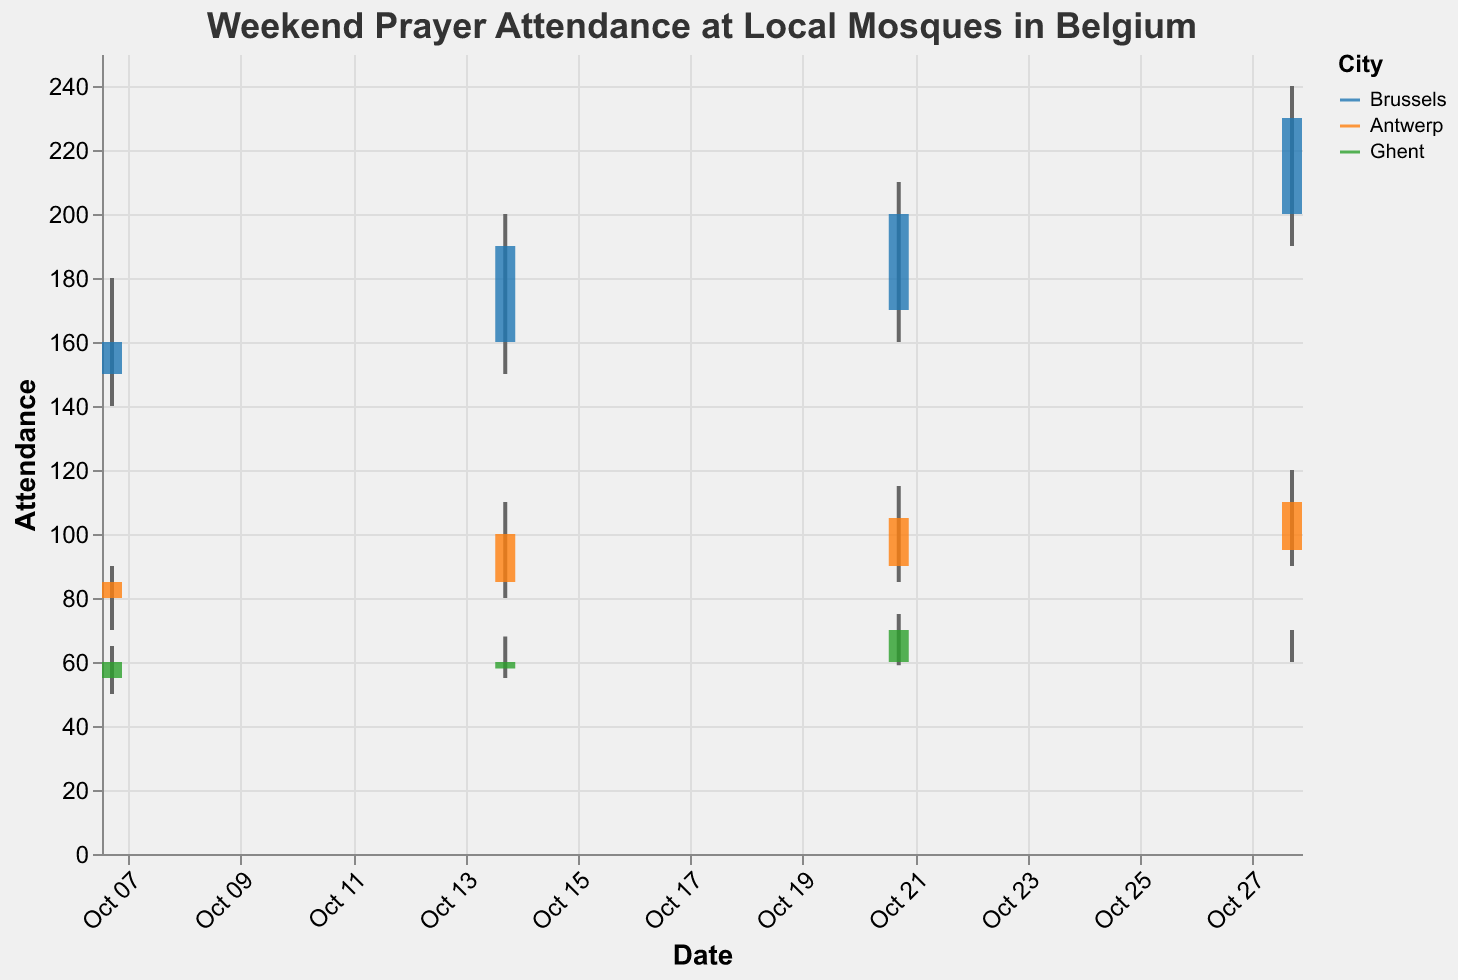What is the title of the plot? The title is usually placed at the top of the plot and specifies what the plot represents.
Answer: Weekend Prayer Attendance at Local Mosques in Belgium Which city has the highest attendance on October 28, 2023? Look at the high values for October 28, 2023, and identify the city with the highest value. Brussels has the highest value with 240 attendees.
Answer: Brussels What is the range of weekend prayer attendance in Ghent on October 21, 2023? The range is calculated as the difference between the high and low values. For Ghent on October 21, 2023: Range = 75 (High) - 59 (Low) = 16.
Answer: 16 Which date shows the lowest closing attendance for Antwerp? Compare the "Close" values for Antwerp across all dates. October 7, 2023, has the lowest closing attendance of 85.
Answer: October 7 What is the total weekend prayer attendance high for Brussels over all dates? Sum the high values for Brussels across the dates: 180 (Oct 7) + 200 (Oct 14) + 210 (Oct 21) + 240 (Oct 28) = 830.
Answer: 830 On which date did Brussels see the highest increase in closing attendance compared to the opening attendance? The increase is calculated as Close - Open for each date. For Brussels: 
  - Oct 7: 160 - 150 = 10
  - Oct 14: 190 - 160 = 30
  - Oct 21: 200 - 170 = 30
  - Oct 28: 230 - 200 = 30
  
Select the highest value. The highest increase is on October 14, 21, and 28, which all have an increase of 30.
Answer: October 14, October 21, October 28 How does the attendance on October 14, 2023, compare between Antwerp and Ghent? Compare the high values of both cities on October 14, 2023: Antwerp has a high of 110 and Ghent has a high of 68. Antwerp’s high is greater.
Answer: Antwerp > Ghent What is the average closing attendance for all cities on October 14, 2023? Sum the closing values for all cities on October 14, 2023, and divide by the number of cities:
  (190 (Brussels) + 100 (Antwerp) + 60 (Ghent)) / 3 = 350 / 3 ≈ 116.67.
Answer: 116.67 